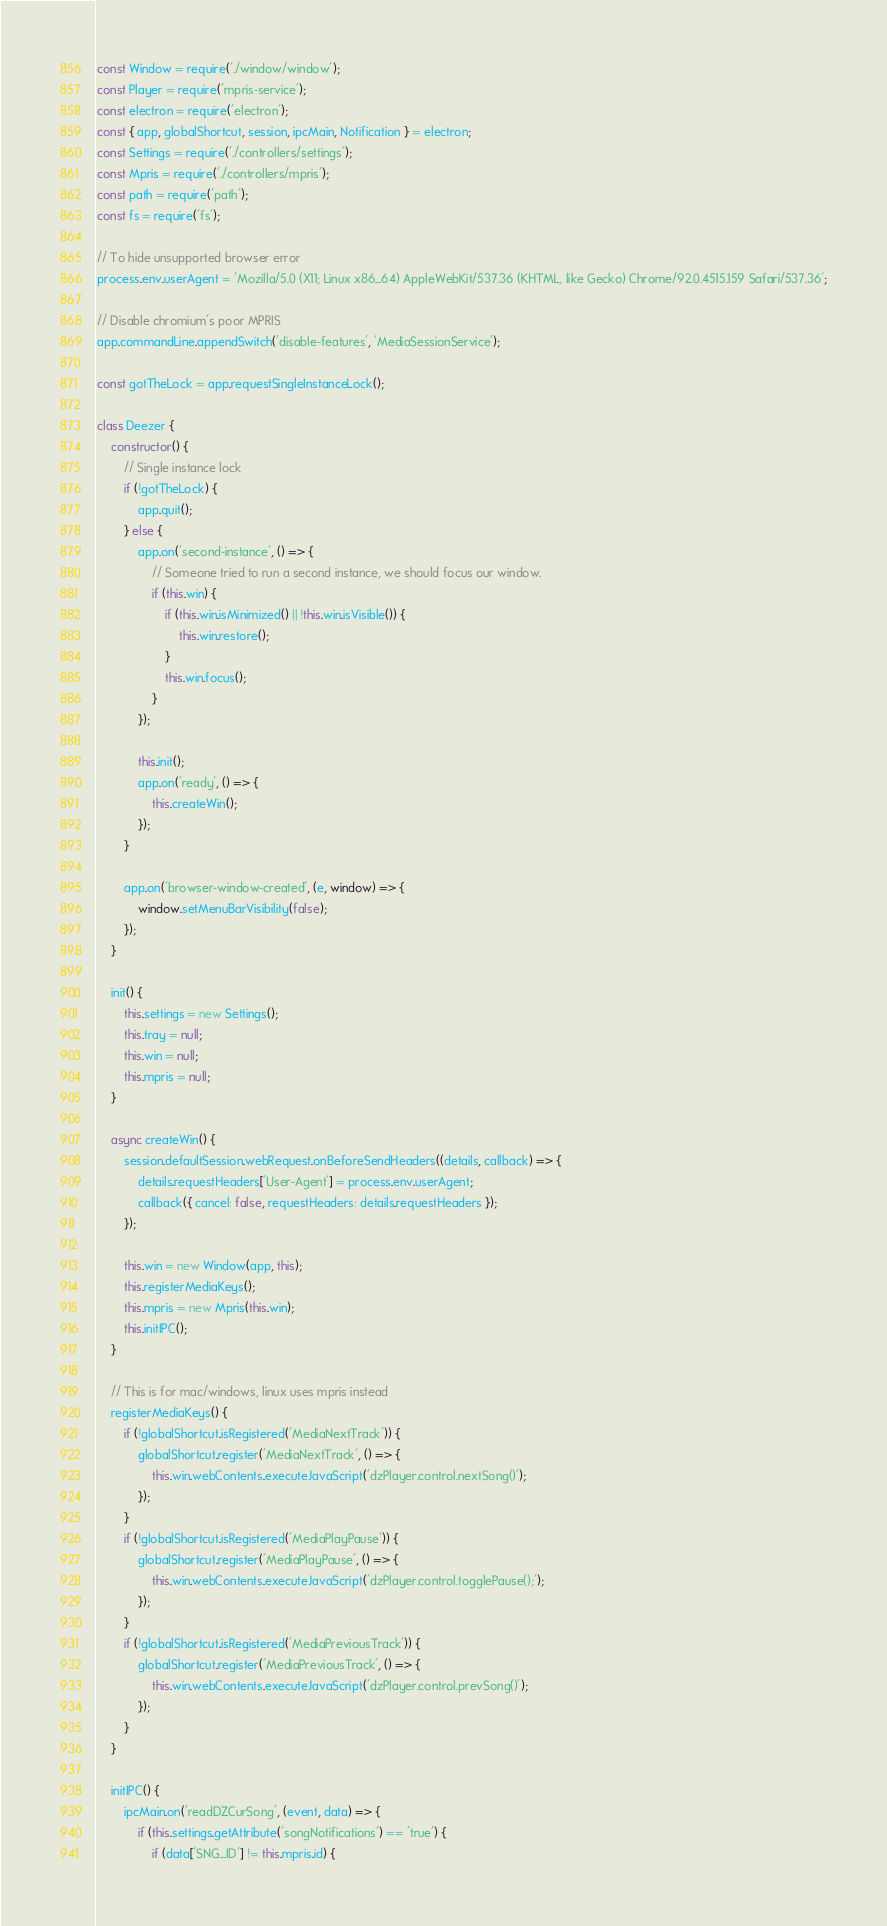Convert code to text. <code><loc_0><loc_0><loc_500><loc_500><_JavaScript_>const Window = require('./window/window');
const Player = require('mpris-service');
const electron = require('electron');
const { app, globalShortcut, session, ipcMain, Notification } = electron;
const Settings = require('./controllers/settings');
const Mpris = require('./controllers/mpris');
const path = require('path');
const fs = require('fs');

// To hide unsupported browser error
process.env.userAgent = 'Mozilla/5.0 (X11; Linux x86_64) AppleWebKit/537.36 (KHTML, like Gecko) Chrome/92.0.4515.159 Safari/537.36';

// Disable chromium's poor MPRIS
app.commandLine.appendSwitch('disable-features', 'MediaSessionService');

const gotTheLock = app.requestSingleInstanceLock();

class Deezer {
    constructor() {
        // Single instance lock
        if (!gotTheLock) {
            app.quit();
        } else {
            app.on('second-instance', () => {
                // Someone tried to run a second instance, we should focus our window.
                if (this.win) {
                    if (this.win.isMinimized() || !this.win.isVisible()) {
                        this.win.restore();
                    }
                    this.win.focus();
                }
            });
            
            this.init();
            app.on('ready', () => {
                this.createWin();
            });
        }
        
        app.on('browser-window-created', (e, window) => {
            window.setMenuBarVisibility(false);
        });
    }
    
    init() {
        this.settings = new Settings();
        this.tray = null;
        this.win = null;
        this.mpris = null;
    }
    
    async createWin() {
        session.defaultSession.webRequest.onBeforeSendHeaders((details, callback) => {
            details.requestHeaders['User-Agent'] = process.env.userAgent;
            callback({ cancel: false, requestHeaders: details.requestHeaders });
        });
        
        this.win = new Window(app, this);
        this.registerMediaKeys();
        this.mpris = new Mpris(this.win);
        this.initIPC();
    }
    
    // This is for mac/windows, linux uses mpris instead
    registerMediaKeys() {
        if (!globalShortcut.isRegistered('MediaNextTrack')) {
            globalShortcut.register('MediaNextTrack', () => {
                this.win.webContents.executeJavaScript('dzPlayer.control.nextSong()');
            });
        }
        if (!globalShortcut.isRegistered('MediaPlayPause')) {
            globalShortcut.register('MediaPlayPause', () => {
                this.win.webContents.executeJavaScript('dzPlayer.control.togglePause();');
            });
        }
        if (!globalShortcut.isRegistered('MediaPreviousTrack')) {
            globalShortcut.register('MediaPreviousTrack', () => {
                this.win.webContents.executeJavaScript('dzPlayer.control.prevSong()');
            });
        }
    }
    
    initIPC() {
        ipcMain.on('readDZCurSong', (event, data) => {
            if (this.settings.getAttribute('songNotifications') == 'true') {
                if (data['SNG_ID'] != this.mpris.id) {</code> 